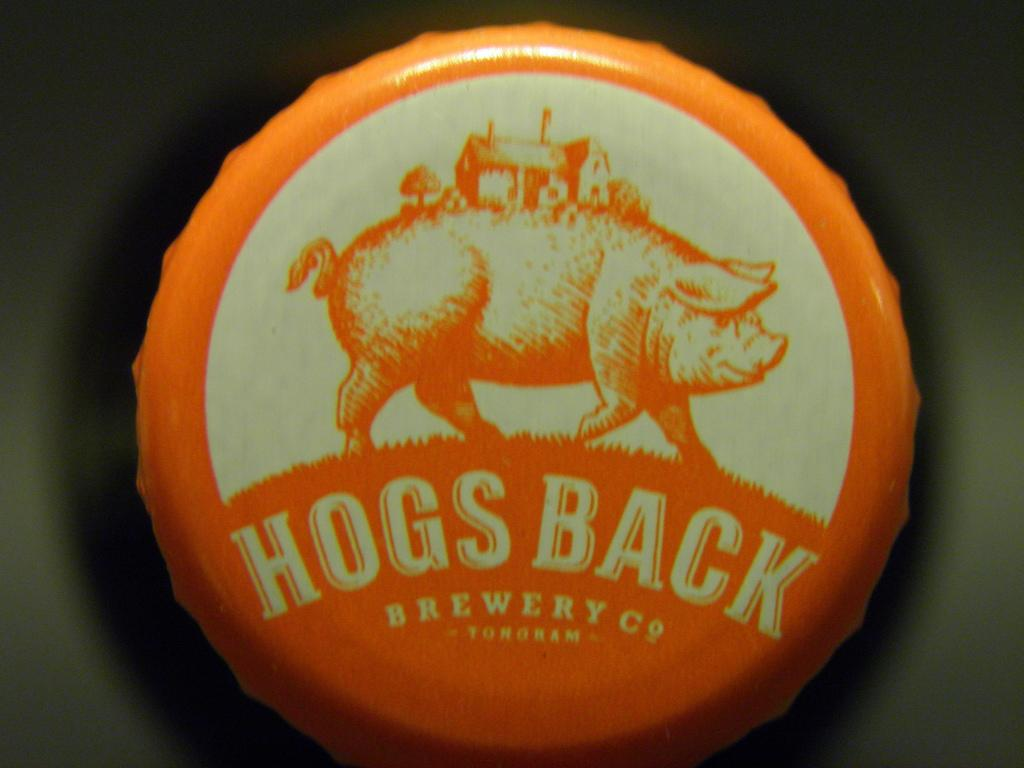What object is featured in the image? There is a bottle cap in the image. What images are present on the bottle cap? The bottle cap has a picture of a pig, a house, and trees. Is there any text on the bottle cap? Yes, there is something written on the bottle cap. What type of holiday is being celebrated in the image? There is no indication of a holiday being celebrated in the image; it features a bottle cap with various images and text. How many circles are visible on the bottle cap? There is no mention of circles in the image; it features a bottle cap with images of a pig, a house, and trees, as well as some text. 